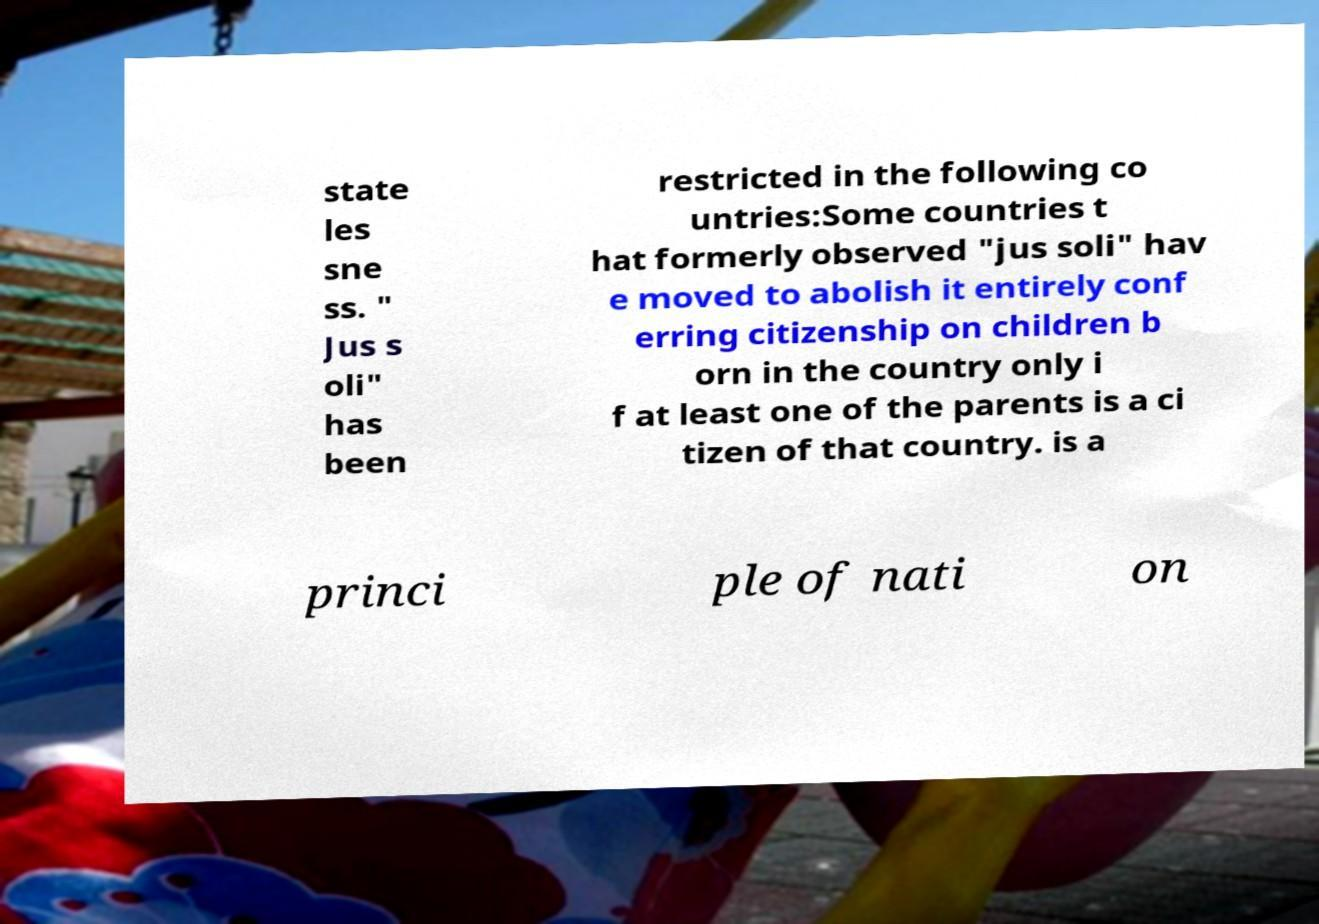Could you assist in decoding the text presented in this image and type it out clearly? state les sne ss. " Jus s oli" has been restricted in the following co untries:Some countries t hat formerly observed "jus soli" hav e moved to abolish it entirely conf erring citizenship on children b orn in the country only i f at least one of the parents is a ci tizen of that country. is a princi ple of nati on 